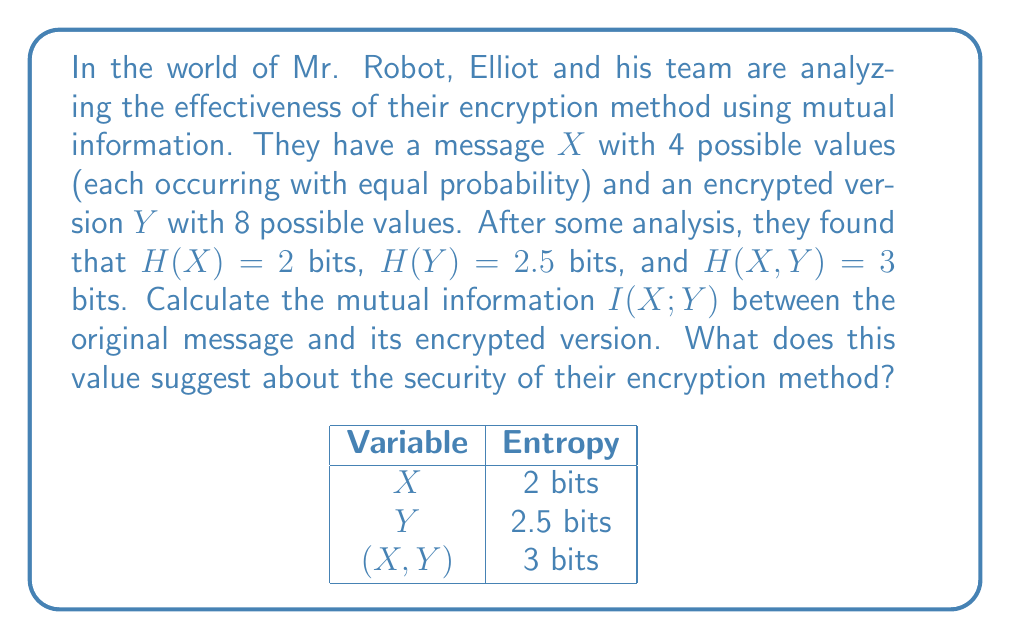Provide a solution to this math problem. Let's approach this step-by-step:

1) The mutual information $I(X;Y)$ is defined as:

   $$I(X;Y) = H(X) + H(Y) - H(X,Y)$$

   where $H(X)$ is the entropy of $X$, $H(Y)$ is the entropy of $Y$, and $H(X,Y)$ is the joint entropy.

2) We are given:
   $H(X) = 2$ bits
   $H(Y) = 2.5$ bits
   $H(X,Y) = 3$ bits

3) Substituting these values into the formula:

   $$I(X;Y) = 2 + 2.5 - 3 = 1.5$$ bits

4) Interpretation:
   - Mutual information measures the amount of information shared between $X$ and $Y$.
   - A value of 1.5 bits suggests that there is still significant information about the original message preserved in the encrypted version.
   - For perfect secrecy, we would want $I(X;Y) = 0$, meaning the encrypted message reveals no information about the original message.
   - The maximum possible value for $I(X;Y)$ in this case is $H(X) = 2$ bits, so 1.5 bits is quite high.

5) Security implication:
   This high mutual information suggests that the encryption method is not very secure. An attacker with access to the encrypted message could potentially deduce significant information about the original message, compromising the confidentiality of Elliot's communications.
Answer: $I(X;Y) = 1.5$ bits; suggests weak encryption 